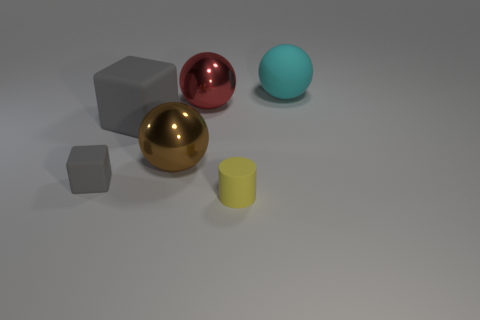Add 2 big yellow matte cylinders. How many objects exist? 8 Subtract all cylinders. How many objects are left? 5 Add 6 small gray blocks. How many small gray blocks are left? 7 Add 5 big cyan rubber cylinders. How many big cyan rubber cylinders exist? 5 Subtract 1 cyan spheres. How many objects are left? 5 Subtract all large red metal objects. Subtract all cyan matte balls. How many objects are left? 4 